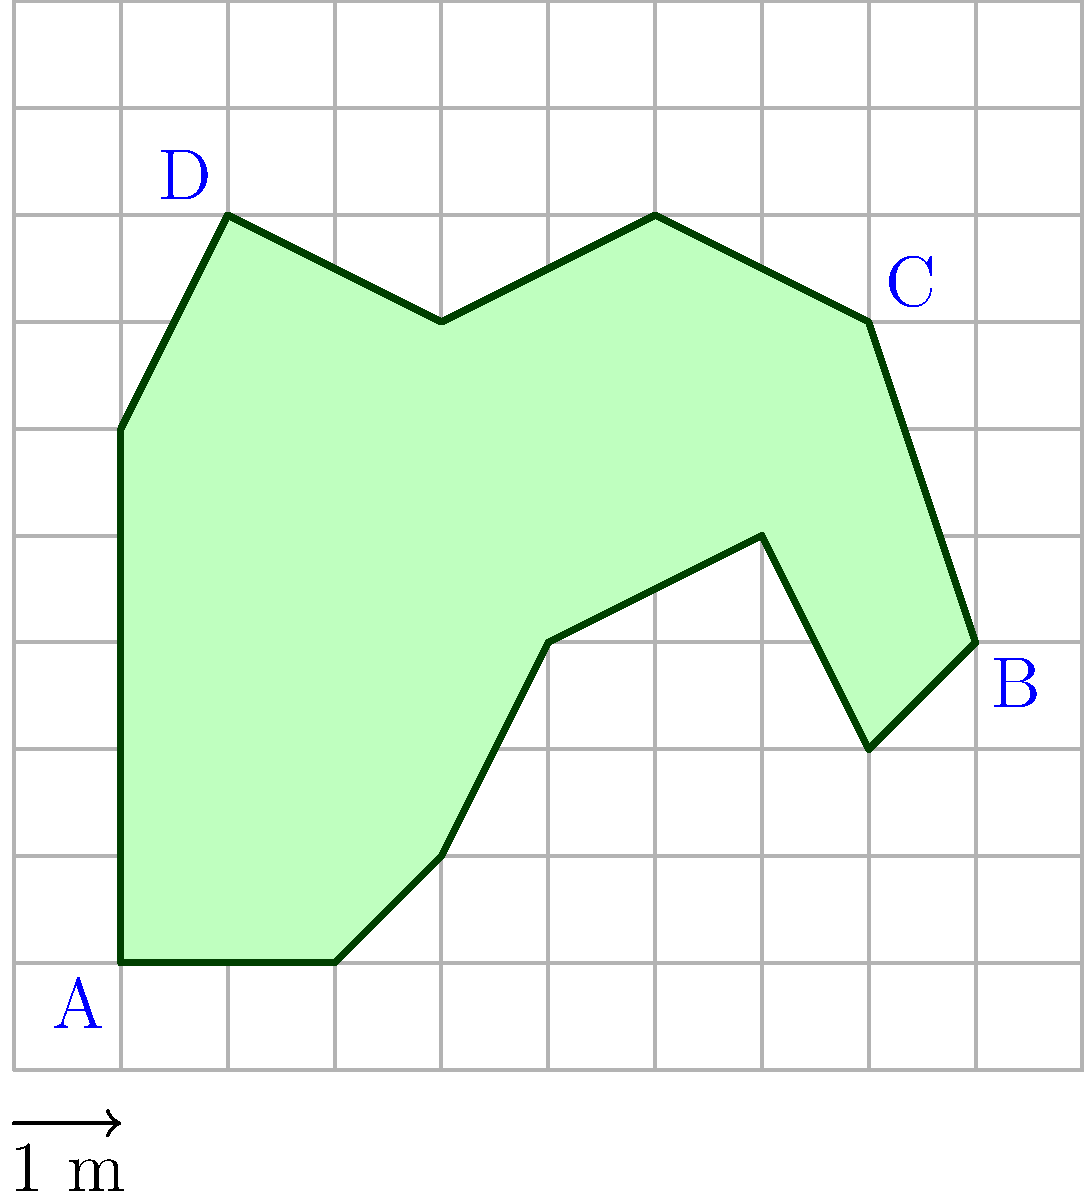In "The Mole," contestants often face challenges that require precise calculations. Imagine you're tasked with finding the center of mass of an irregularly shaped object, which could be a clue to the Mole's identity. The object's 2D outline is shown on a grid, where each square represents 1 m x 1 m. Assuming the object has uniform density, what are the x and y coordinates of its center of mass? Give your answer to the nearest 0.1 m. To find the center of mass of an irregularly shaped object with uniform density, we can use the method of dividing the shape into simpler geometric forms and then calculate the weighted average of their individual centers of mass. Here's how we can approach this problem:

1. Divide the shape into triangles and rectangles.
2. Calculate the area and center of mass for each shape.
3. Use the formula: $x_{cm} = \frac{\sum x_i A_i}{\sum A_i}$ and $y_{cm} = \frac{\sum y_i A_i}{\sum A_i}$

Let's break it down:

1. Rectangle 1: (1,1) to (3,1) to (3,6) to (1,6)
   Area = 2 * 5 = 10 m²
   Center: (2, 3.5)

2. Triangle 1: (3,1) to (4,2) to (3,2)
   Area = 0.5 * 1 * 1 = 0.5 m²
   Center: (3.33, 1.67)

3. Triangle 2: (3,6) to (4,7) to (3,7)
   Area = 0.5 * 1 * 1 = 0.5 m²
   Center: (3.33, 6.67)

4. Trapezoid: (3,2) to (4,2) to (5,4) to (7,5) to (8,3) to (9,4) to (8,7) to (6,8) to (4,7) to (3,6)
   Area ≈ 21 m² (approximated)
   Center: (6, 5) (approximated)

Now, let's apply the center of mass formula:

$x_{cm} = \frac{(2*10) + (3.33*0.5) + (3.33*0.5) + (6*21)}{10 + 0.5 + 0.5 + 21} \approx 4.7$ m

$y_{cm} = \frac{(3.5*10) + (1.67*0.5) + (6.67*0.5) + (5*21)}{10 + 0.5 + 0.5 + 21} \approx 4.6$ m

Rounding to the nearest 0.1 m, we get (4.7, 4.6).
Answer: (4.7, 4.6) 